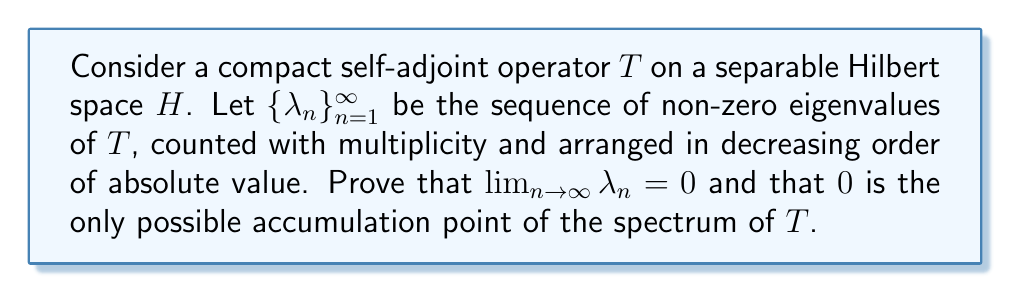Could you help me with this problem? Let's approach this proof step by step:

1) First, recall that for a compact self-adjoint operator $T$ on a Hilbert space $H$, the spectral theorem states that there exists an orthonormal basis of $H$ consisting of eigenvectors of $T$.

2) Let $\{\lambda_n\}_{n=1}^{\infty}$ be the sequence of non-zero eigenvalues of $T$, and $\{e_n\}_{n=1}^{\infty}$ be the corresponding orthonormal eigenvectors.

3) We can represent $T$ as:

   $$T = \sum_{n=1}^{\infty} \lambda_n (e_n \otimes e_n)$$

   where $(e_n \otimes e_n)(x) = \langle x, e_n \rangle e_n$.

4) Now, let's consider the partial sums:

   $$T_N = \sum_{n=1}^{N} \lambda_n (e_n \otimes e_n)$$

5) The operator norm of $T - T_N$ is:

   $$\|T - T_N\| = \sup_{\|x\|=1} \|(T-T_N)x\| = \sup_{\|x\|=1} \left\|\sum_{n=N+1}^{\infty} \lambda_n \langle x, e_n \rangle e_n\right\|$$

6) Using the Cauchy-Schwarz inequality and the fact that $\{e_n\}$ is orthonormal:

   $$\|T - T_N\|^2 \leq \sup_{\|x\|=1} \sum_{n=N+1}^{\infty} |\lambda_n|^2 |\langle x, e_n \rangle|^2 \leq \sum_{n=N+1}^{\infty} |\lambda_n|^2$$

7) Since $T$ is compact, we know that $\lim_{N \to \infty} \|T - T_N\| = 0$. This implies:

   $$\lim_{N \to \infty} \sum_{n=N+1}^{\infty} |\lambda_n|^2 = 0$$

8) This is only possible if $\lim_{n \to \infty} \lambda_n = 0$.

9) Now, let's consider the spectrum of $T$. We know that for a compact operator, every non-zero spectral value is an eigenvalue.

10) Suppose $\mu$ is an accumulation point of the spectrum. Then there exists a sequence of distinct eigenvalues $\{\lambda_{n_k}\}$ converging to $\mu$.

11) But we've shown that $\lim_{n \to \infty} \lambda_n = 0$, so the only possible value for $\mu$ is 0.

Therefore, we have proven that $\lim_{n \to \infty} \lambda_n = 0$ and that 0 is the only possible accumulation point of the spectrum of $T$.
Answer: $\lim_{n \to \infty} \lambda_n = 0$, and 0 is the only possible accumulation point of the spectrum of $T$. 